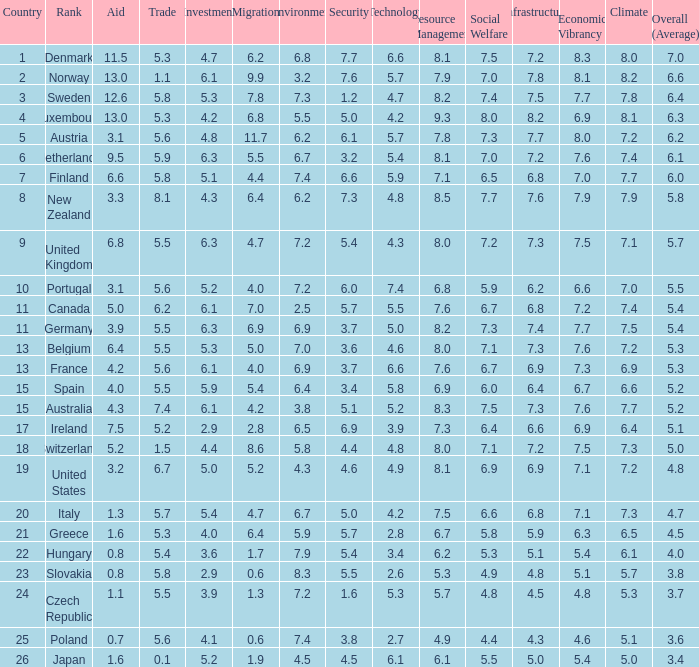What country has a 5.5 mark for security? Slovakia. 